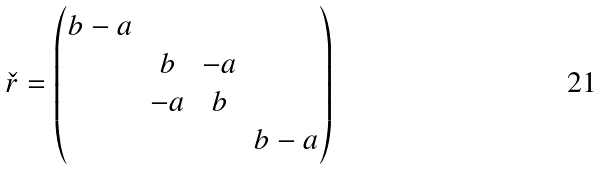<formula> <loc_0><loc_0><loc_500><loc_500>\check { r } = \begin{pmatrix} b - a & & & \\ & b & - a & \\ & - a & b & \\ & & & b - a \end{pmatrix}</formula> 